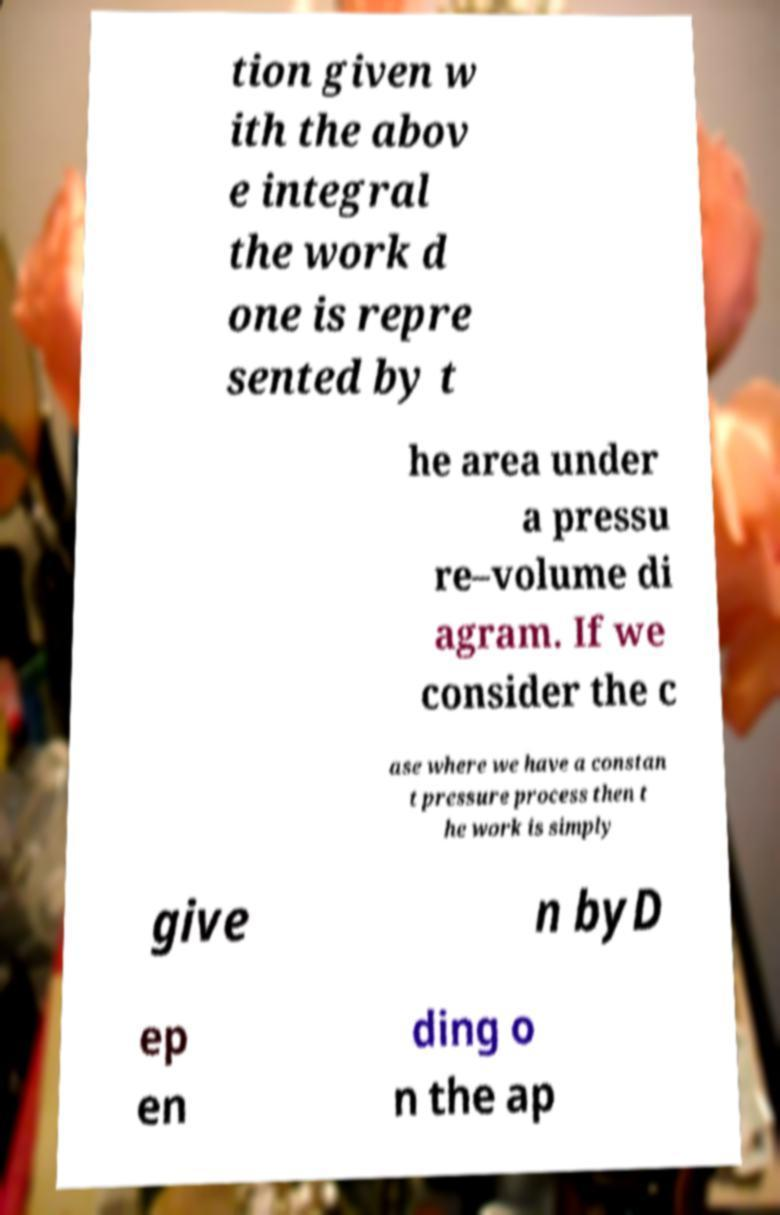I need the written content from this picture converted into text. Can you do that? tion given w ith the abov e integral the work d one is repre sented by t he area under a pressu re–volume di agram. If we consider the c ase where we have a constan t pressure process then t he work is simply give n byD ep en ding o n the ap 